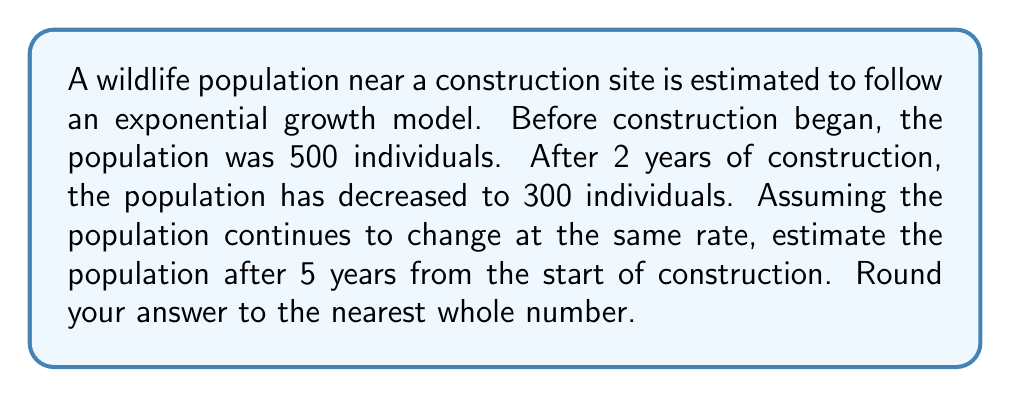Can you solve this math problem? To solve this problem, we'll use the exponential growth model:

$$ P(t) = P_0 e^{rt} $$

Where:
$P(t)$ is the population at time $t$
$P_0$ is the initial population
$r$ is the growth rate
$t$ is the time

1. First, let's find the growth rate $r$:
   We know that $P_0 = 500$ and after 2 years, $P(2) = 300$

   $300 = 500e^{2r}$

2. Solve for $r$:
   $\frac{300}{500} = e^{2r}$
   $\ln(\frac{3}{5}) = 2r$
   $r = \frac{\ln(\frac{3}{5})}{2} \approx -0.2554$

3. Now that we have $r$, we can estimate the population after 5 years:

   $P(5) = 500e^{-0.2554 * 5}$

4. Calculate:
   $P(5) = 500e^{-1.277} \approx 139.65$

5. Rounding to the nearest whole number:
   $P(5) \approx 140$
Answer: 140 individuals 